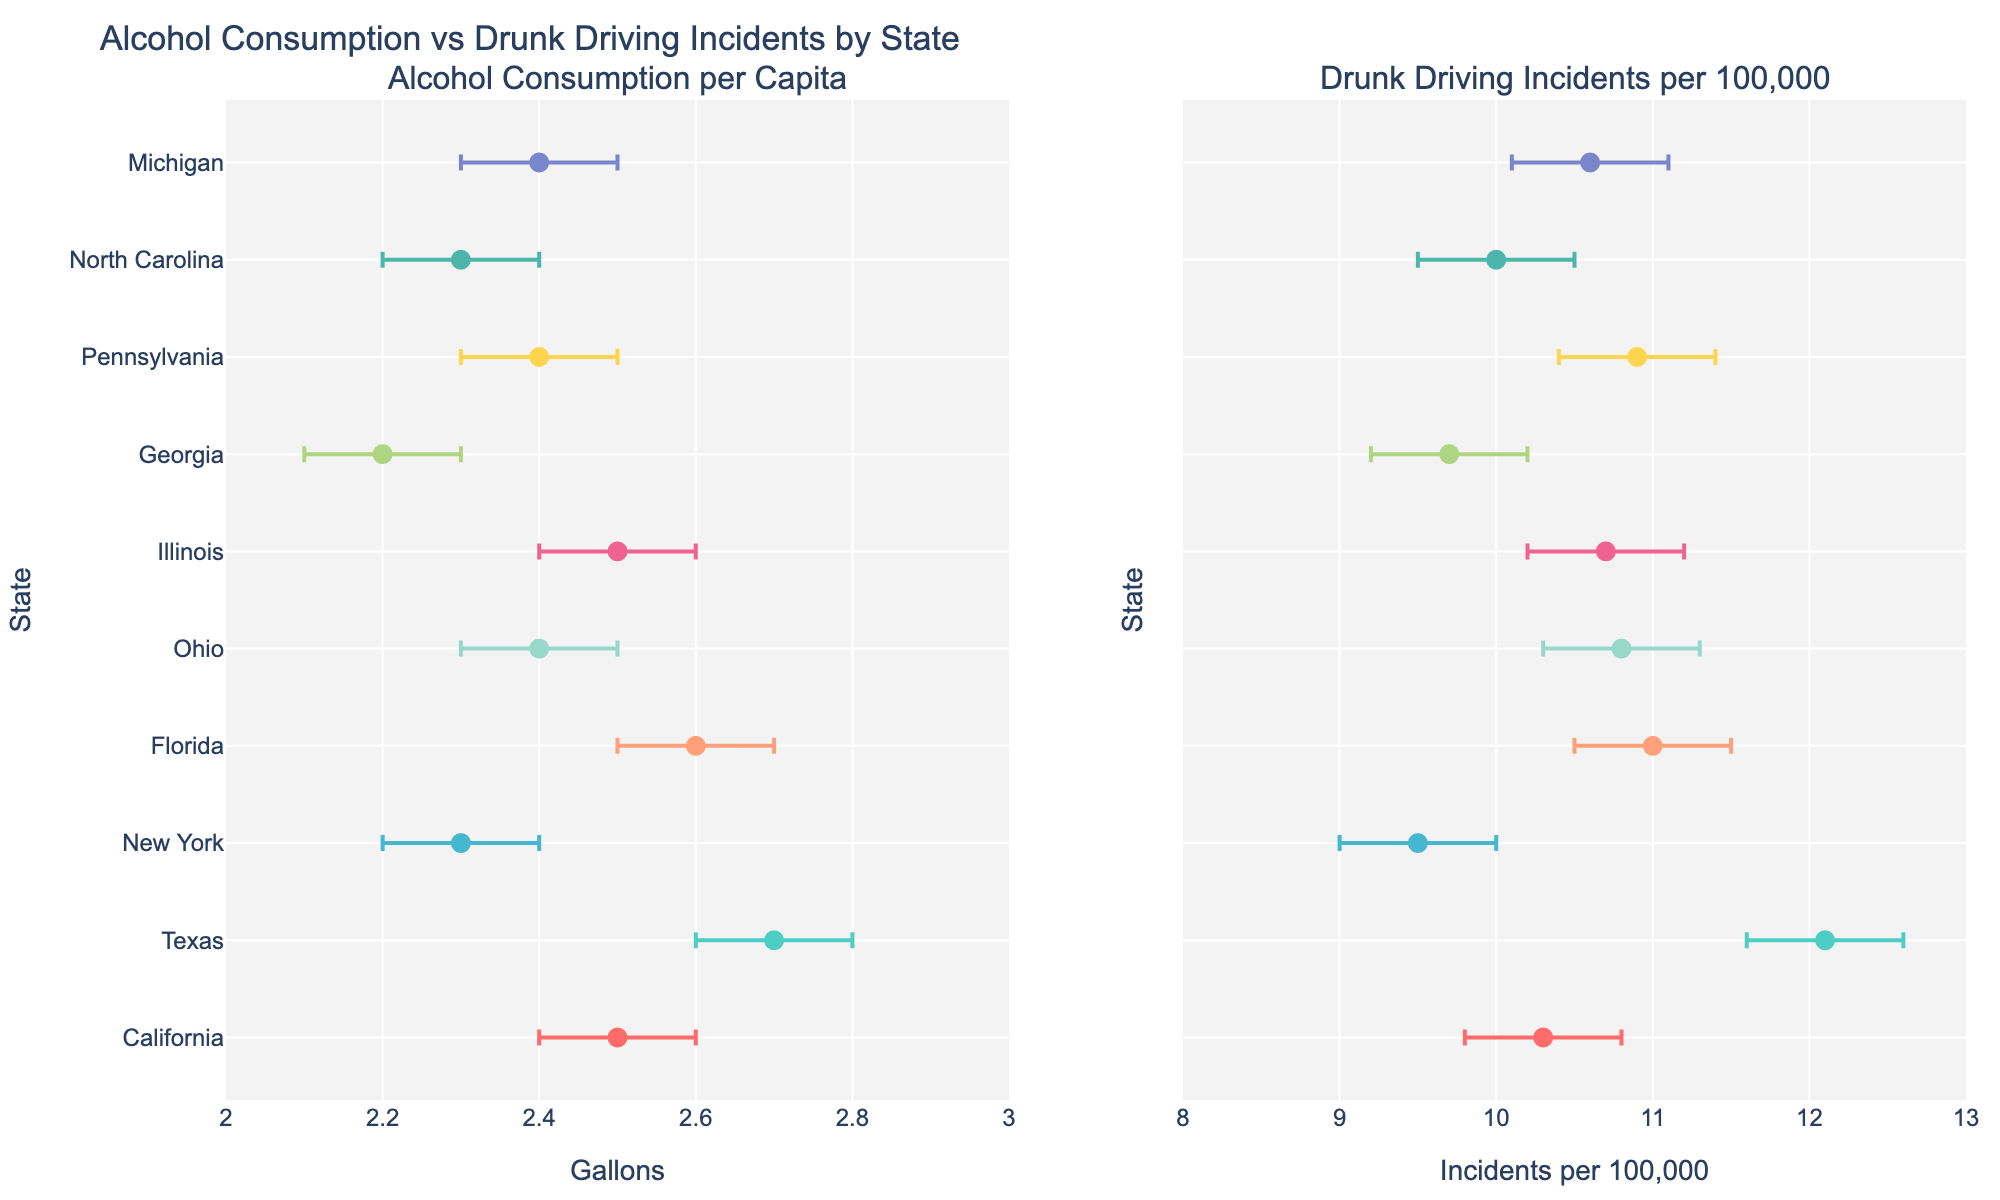How many states are directly represented in this figure? Simply count the number of unique states listed in both subplots. Each subplot represents the same set of states.
Answer: 10 Which state has the highest alcohol consumption per capita? Examine the first subplot titled "Alcohol Consumption per Capita" and find the state with the highest x-axis value.
Answer: Texas What is the range of drunk driving incidents per 100,000 for Florida? Find Florida in the second subplot titled "Drunk Driving Incidents per 100,000" and refer to the error bars which represent the confidence interval. The upper limit is 11.5 and the lower limit is 10.5. The range is calculated by subtracting the lower limit from the upper limit.
Answer: 1.0 Which state has the smallest range in alcohol consumption based on the confidence intervals? Compare the error bars for alcohol consumption across all states in the first subplot. The state with the narrowest error bar has the smallest range.
Answer: Georgia Are there any states where the 95% confidence intervals of drunk driving incidents overlap with each other? Check the error bars in the second subplot titled "Drunk Driving Incidents per 100,000". Overlapping intervals imply that the intervals of some states coincide even partially. Several states might have overlapping intervals.
Answer: Yes Which state has similar levels of both alcohol consumption per capita and drunk driving incidents per 100,000, considering the intervals? Identify a state where both plots have similar x-axis values given their error bars. Look for coinciding data points and overlapping intervals.
Answer: Illinois For which state are the confidence intervals widest for both metrics? Observe both subplots and compare the lengths of the error bars. The state with the largest combined length of the error bars on both metrics is the answer.
Answer: Texas If you were to focus on one state whose drunk driving incidents number lies more towards the lower end of their confidence interval, which state would it be? Analyze the second subplot to see which state's actual data point is closest to the lower bound of their interval.
Answer: New York 